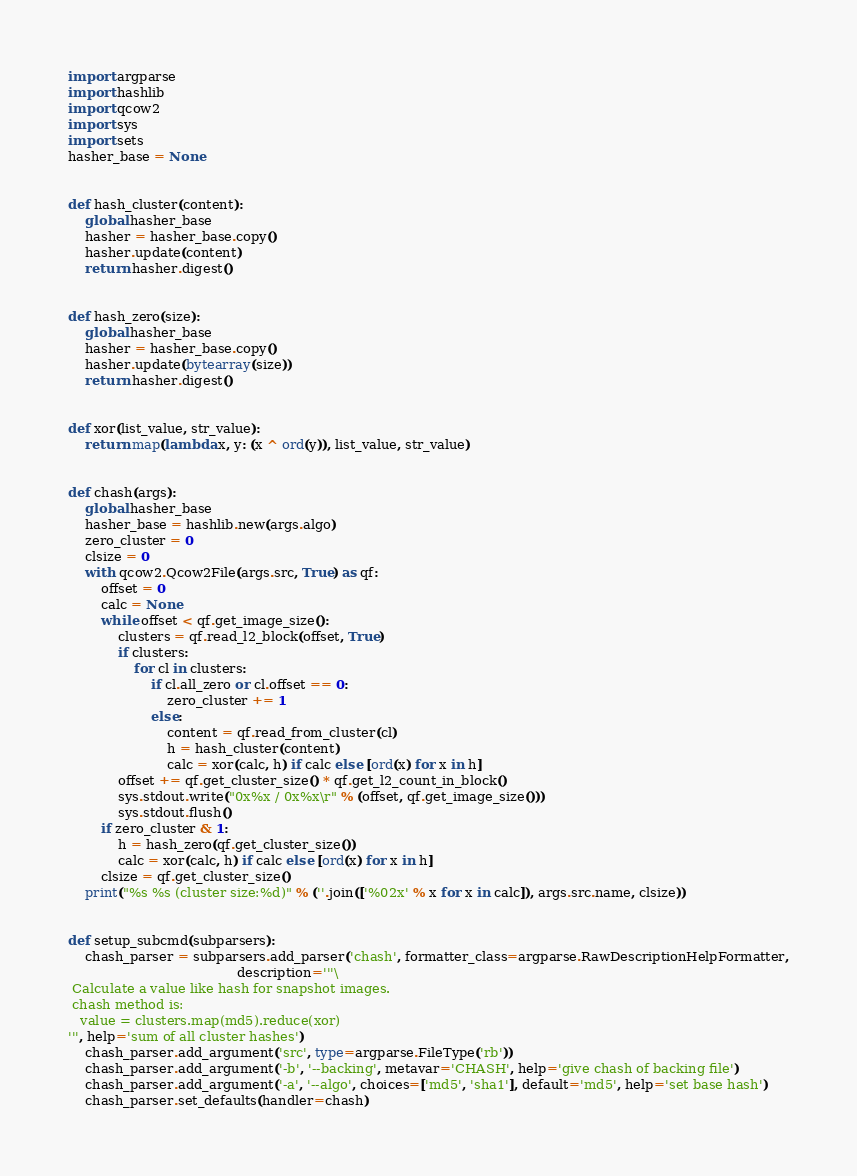<code> <loc_0><loc_0><loc_500><loc_500><_Python_>import argparse
import hashlib
import qcow2
import sys
import sets
hasher_base = None


def hash_cluster(content):
    global hasher_base
    hasher = hasher_base.copy()
    hasher.update(content)
    return hasher.digest()


def hash_zero(size):
    global hasher_base
    hasher = hasher_base.copy()
    hasher.update(bytearray(size))
    return hasher.digest()


def xor(list_value, str_value):
    return map(lambda x, y: (x ^ ord(y)), list_value, str_value)


def chash(args):
    global hasher_base
    hasher_base = hashlib.new(args.algo)
    zero_cluster = 0
    clsize = 0
    with qcow2.Qcow2File(args.src, True) as qf:
        offset = 0
        calc = None
        while offset < qf.get_image_size():
            clusters = qf.read_l2_block(offset, True)
            if clusters:
                for cl in clusters:
                    if cl.all_zero or cl.offset == 0:
                        zero_cluster += 1
                    else:
                        content = qf.read_from_cluster(cl)
                        h = hash_cluster(content)
                        calc = xor(calc, h) if calc else [ord(x) for x in h]
            offset += qf.get_cluster_size() * qf.get_l2_count_in_block()
            sys.stdout.write("0x%x / 0x%x\r" % (offset, qf.get_image_size()))
            sys.stdout.flush()
        if zero_cluster & 1:
            h = hash_zero(qf.get_cluster_size())
            calc = xor(calc, h) if calc else [ord(x) for x in h]
        clsize = qf.get_cluster_size()
    print("%s %s (cluster size:%d)" % (''.join(['%02x' % x for x in calc]), args.src.name, clsize))


def setup_subcmd(subparsers):
    chash_parser = subparsers.add_parser('chash', formatter_class=argparse.RawDescriptionHelpFormatter,
                                         description='''\
 Calculate a value like hash for snapshot images.
 chash method is:
   value = clusters.map(md5).reduce(xor)
''', help='sum of all cluster hashes')
    chash_parser.add_argument('src', type=argparse.FileType('rb'))
    chash_parser.add_argument('-b', '--backing', metavar='CHASH', help='give chash of backing file')
    chash_parser.add_argument('-a', '--algo', choices=['md5', 'sha1'], default='md5', help='set base hash')
    chash_parser.set_defaults(handler=chash)
</code> 